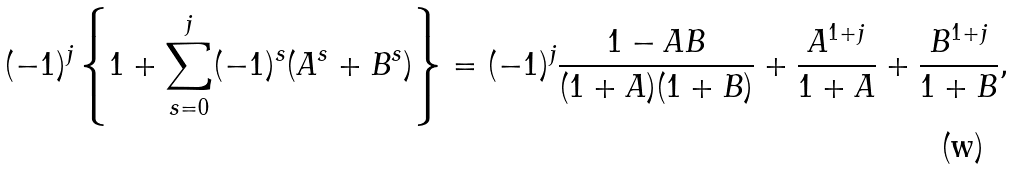<formula> <loc_0><loc_0><loc_500><loc_500>( - 1 ) ^ { j } \left \{ 1 + \sum _ { s = 0 } ^ { j } ( - 1 ) ^ { s } ( A ^ { s } + B ^ { s } ) \right \} = ( - 1 ) ^ { j } \frac { 1 - A B } { ( 1 + A ) ( 1 + B ) } + \frac { A ^ { 1 + j } } { 1 + A } + \frac { B ^ { 1 + j } } { 1 + B } ,</formula> 